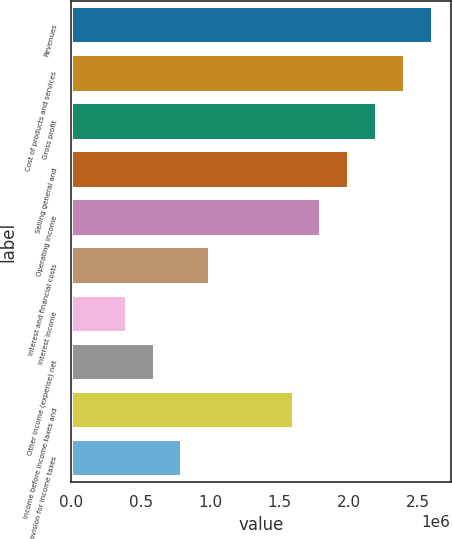<chart> <loc_0><loc_0><loc_500><loc_500><bar_chart><fcel>Revenues<fcel>Cost of products and services<fcel>Gross profit<fcel>Selling general and<fcel>Operating income<fcel>Interest and financial costs<fcel>Interest income<fcel>Other income (expense) net<fcel>Income before income taxes and<fcel>Provision for income taxes<nl><fcel>2.6064e+06<fcel>2.4059e+06<fcel>2.20541e+06<fcel>2.00492e+06<fcel>1.80443e+06<fcel>1.00246e+06<fcel>400985<fcel>601477<fcel>1.60394e+06<fcel>801969<nl></chart> 